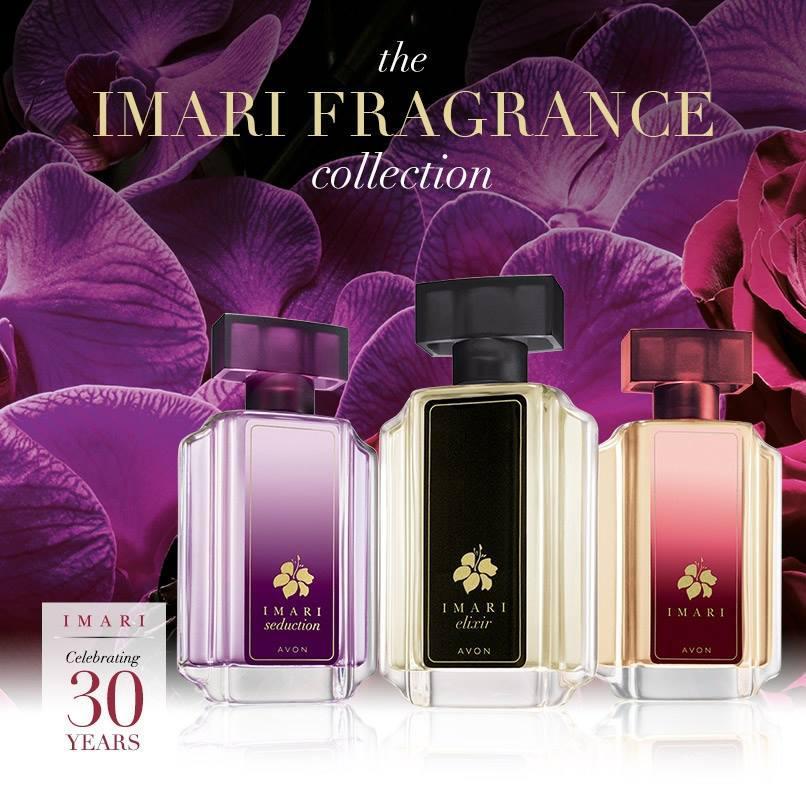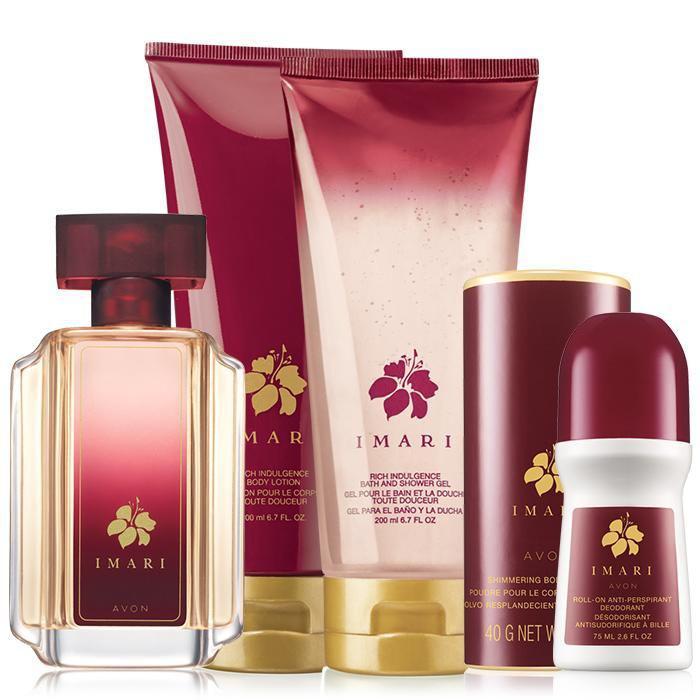The first image is the image on the left, the second image is the image on the right. Examine the images to the left and right. Is the description "A purple perfume bottle is to the left of a black bottle and a red bottle." accurate? Answer yes or no. Yes. The first image is the image on the left, the second image is the image on the right. For the images displayed, is the sentence "The image on the left contains only one bottle of fragrance, and its box." factually correct? Answer yes or no. No. 